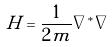Convert formula to latex. <formula><loc_0><loc_0><loc_500><loc_500>H = \frac { 1 } { 2 m } \nabla ^ { * } \nabla</formula> 